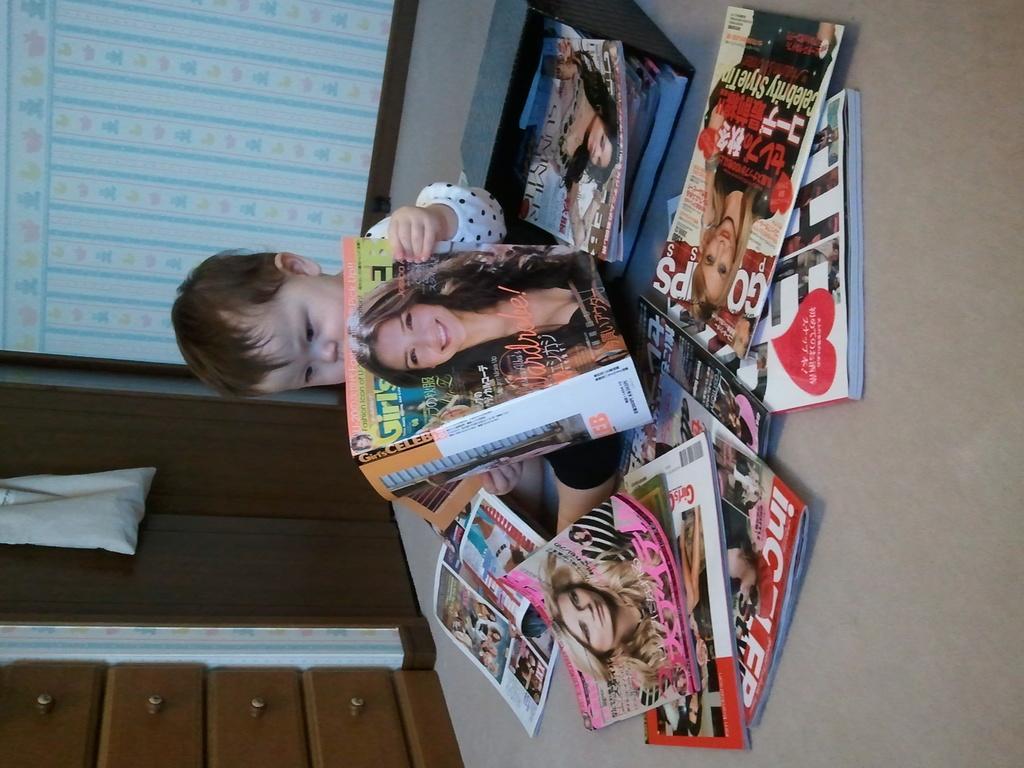Describe this image in one or two sentences. There are many books on the floor. And a baby is sitting on the floor and holding a book. In the back there is a wall with cupboard. 